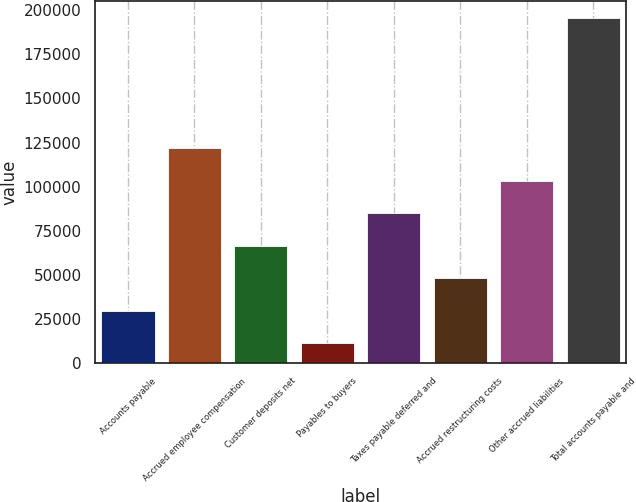<chart> <loc_0><loc_0><loc_500><loc_500><bar_chart><fcel>Accounts payable<fcel>Accrued employee compensation<fcel>Customer deposits net<fcel>Payables to buyers<fcel>Taxes payable deferred and<fcel>Accrued restructuring costs<fcel>Other accrued liabilities<fcel>Total accounts payable and<nl><fcel>29726.8<fcel>121676<fcel>66506.4<fcel>11337<fcel>84896.2<fcel>48116.6<fcel>103286<fcel>195235<nl></chart> 